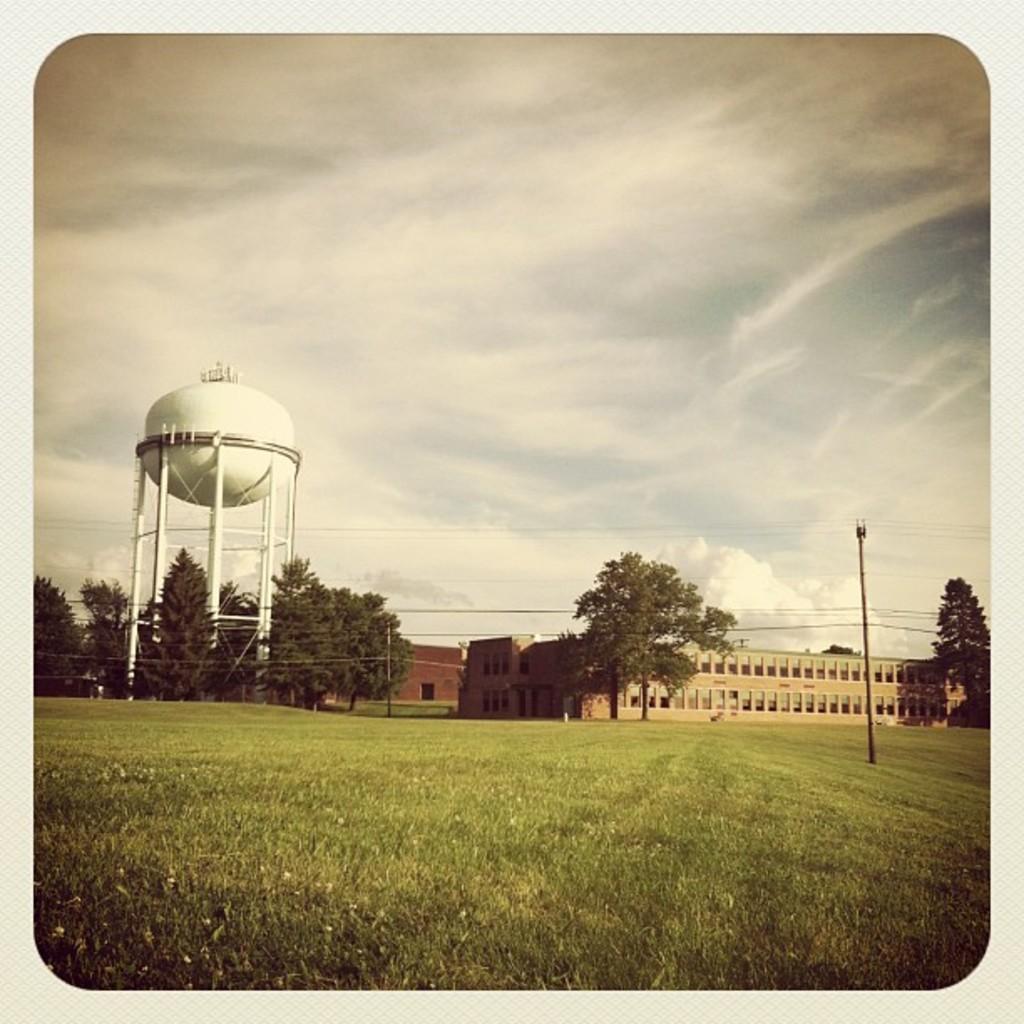Describe this image in one or two sentences. This image is taken outdoors. At the bottom of the image there is a ground with grass on it. At the top of the image there is a sky with clouds. In the background there are a few buildings, trees and a tank and there is a pole with wires. 